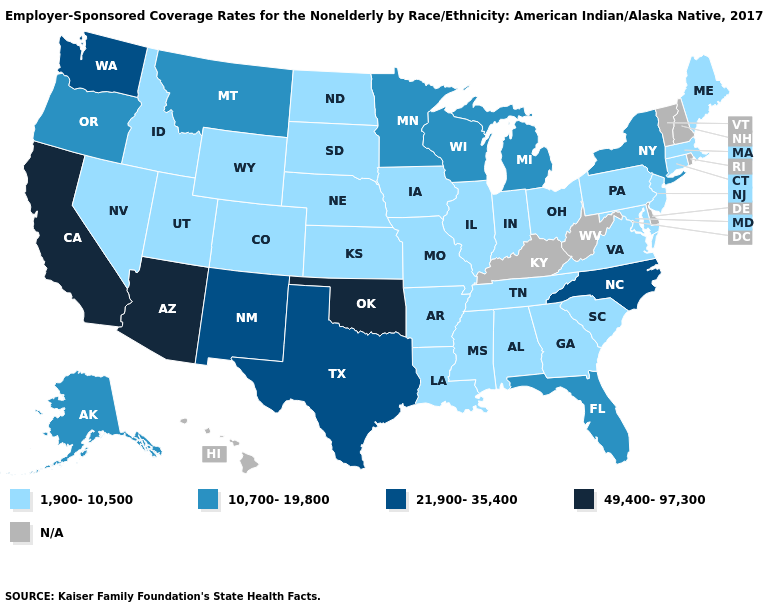Among the states that border Louisiana , does Texas have the lowest value?
Short answer required. No. How many symbols are there in the legend?
Give a very brief answer. 5. Which states hav the highest value in the MidWest?
Short answer required. Michigan, Minnesota, Wisconsin. What is the value of Oklahoma?
Write a very short answer. 49,400-97,300. Does North Carolina have the lowest value in the USA?
Concise answer only. No. Does Louisiana have the lowest value in the USA?
Keep it brief. Yes. Does the map have missing data?
Be succinct. Yes. Does South Carolina have the highest value in the South?
Concise answer only. No. Does California have the highest value in the USA?
Answer briefly. Yes. Name the states that have a value in the range 10,700-19,800?
Keep it brief. Alaska, Florida, Michigan, Minnesota, Montana, New York, Oregon, Wisconsin. Does New York have the lowest value in the Northeast?
Be succinct. No. Does Michigan have the lowest value in the USA?
Keep it brief. No. 